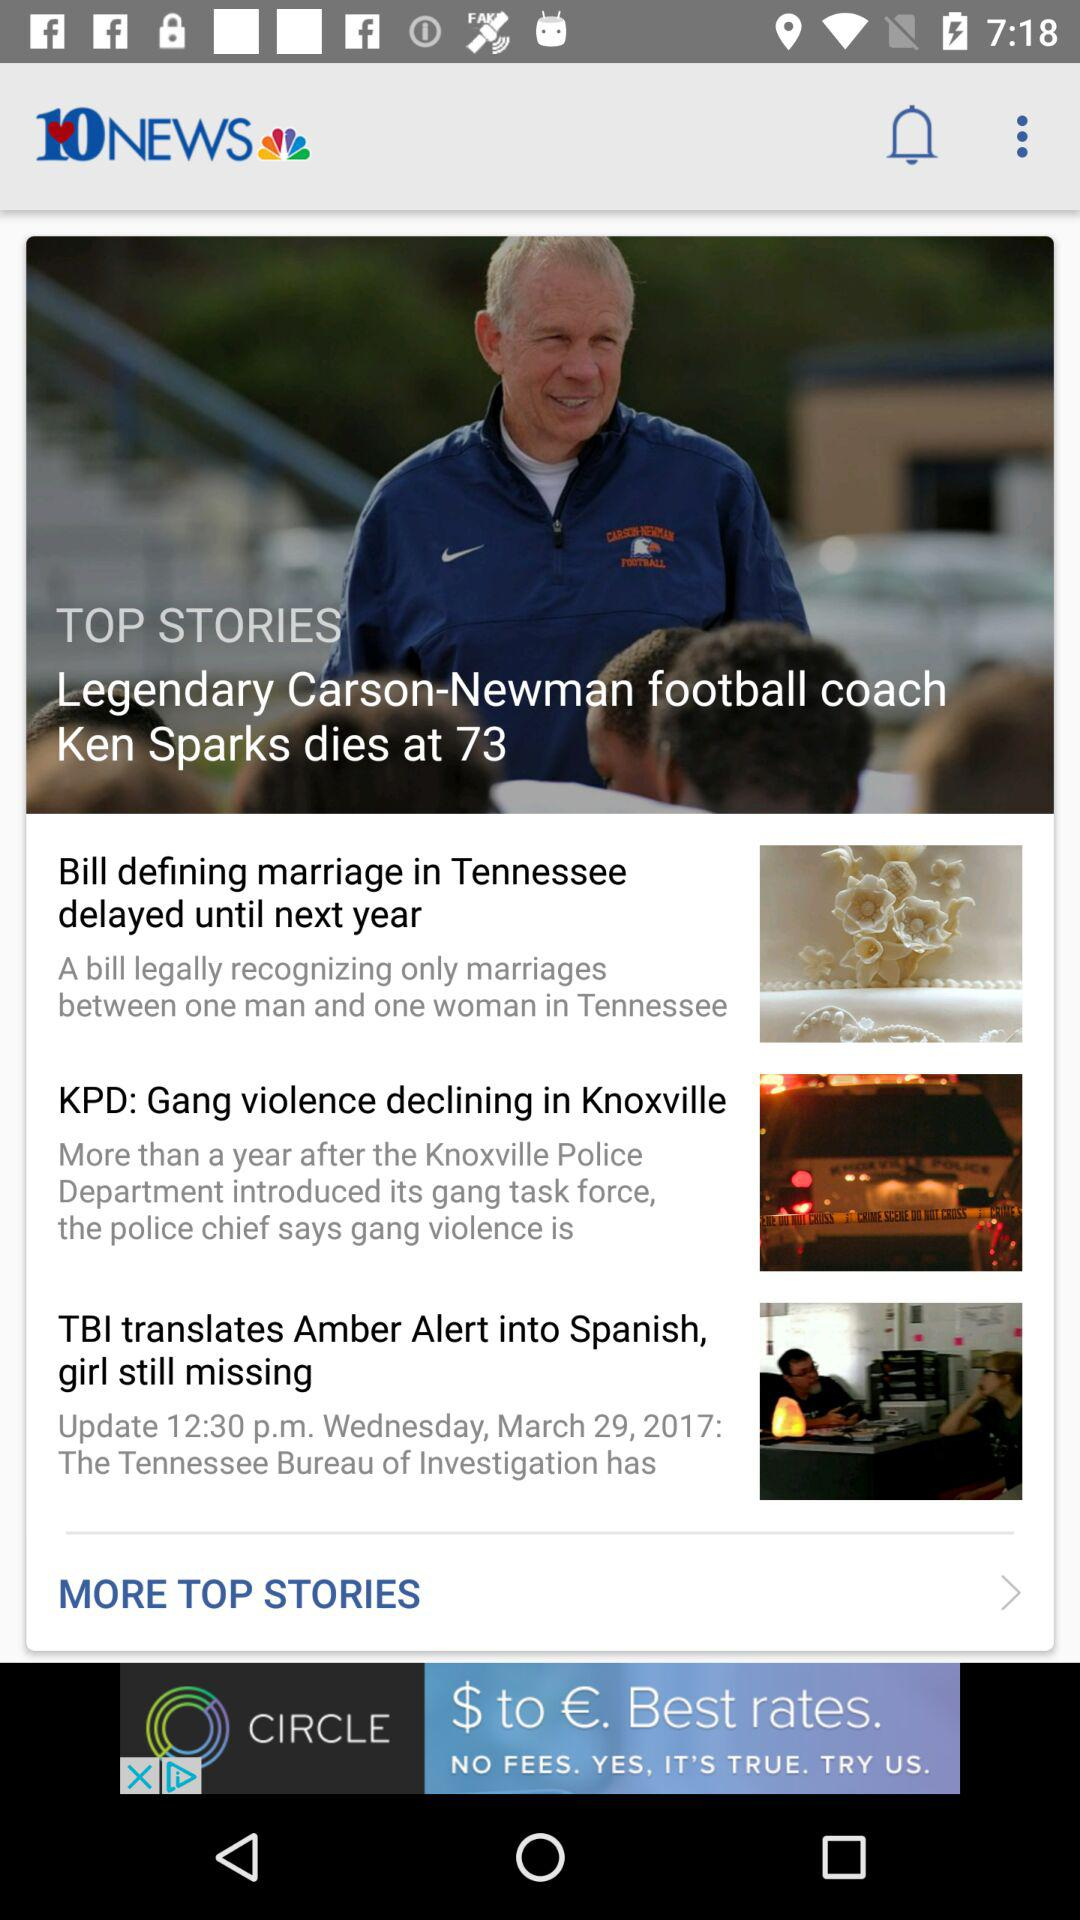What is the application name? The application name is "10NEWS". 